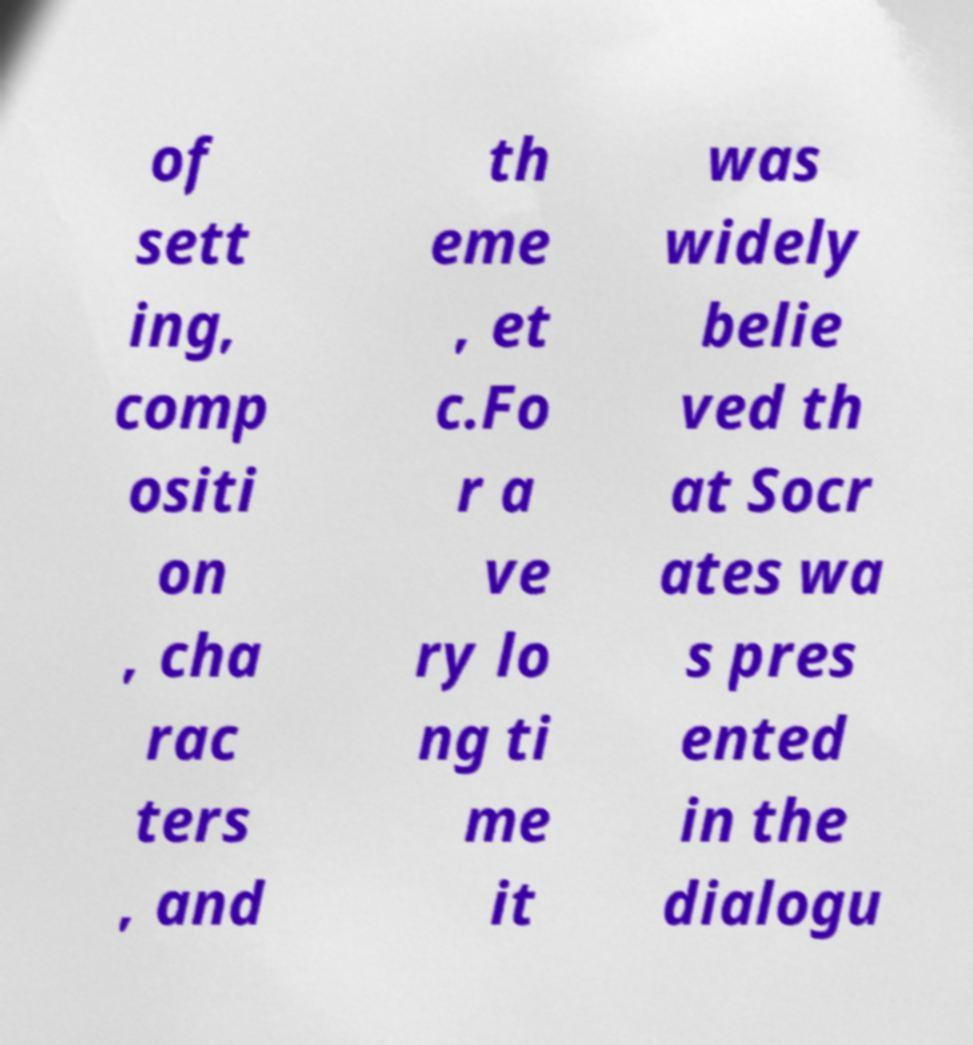Could you extract and type out the text from this image? of sett ing, comp ositi on , cha rac ters , and th eme , et c.Fo r a ve ry lo ng ti me it was widely belie ved th at Socr ates wa s pres ented in the dialogu 